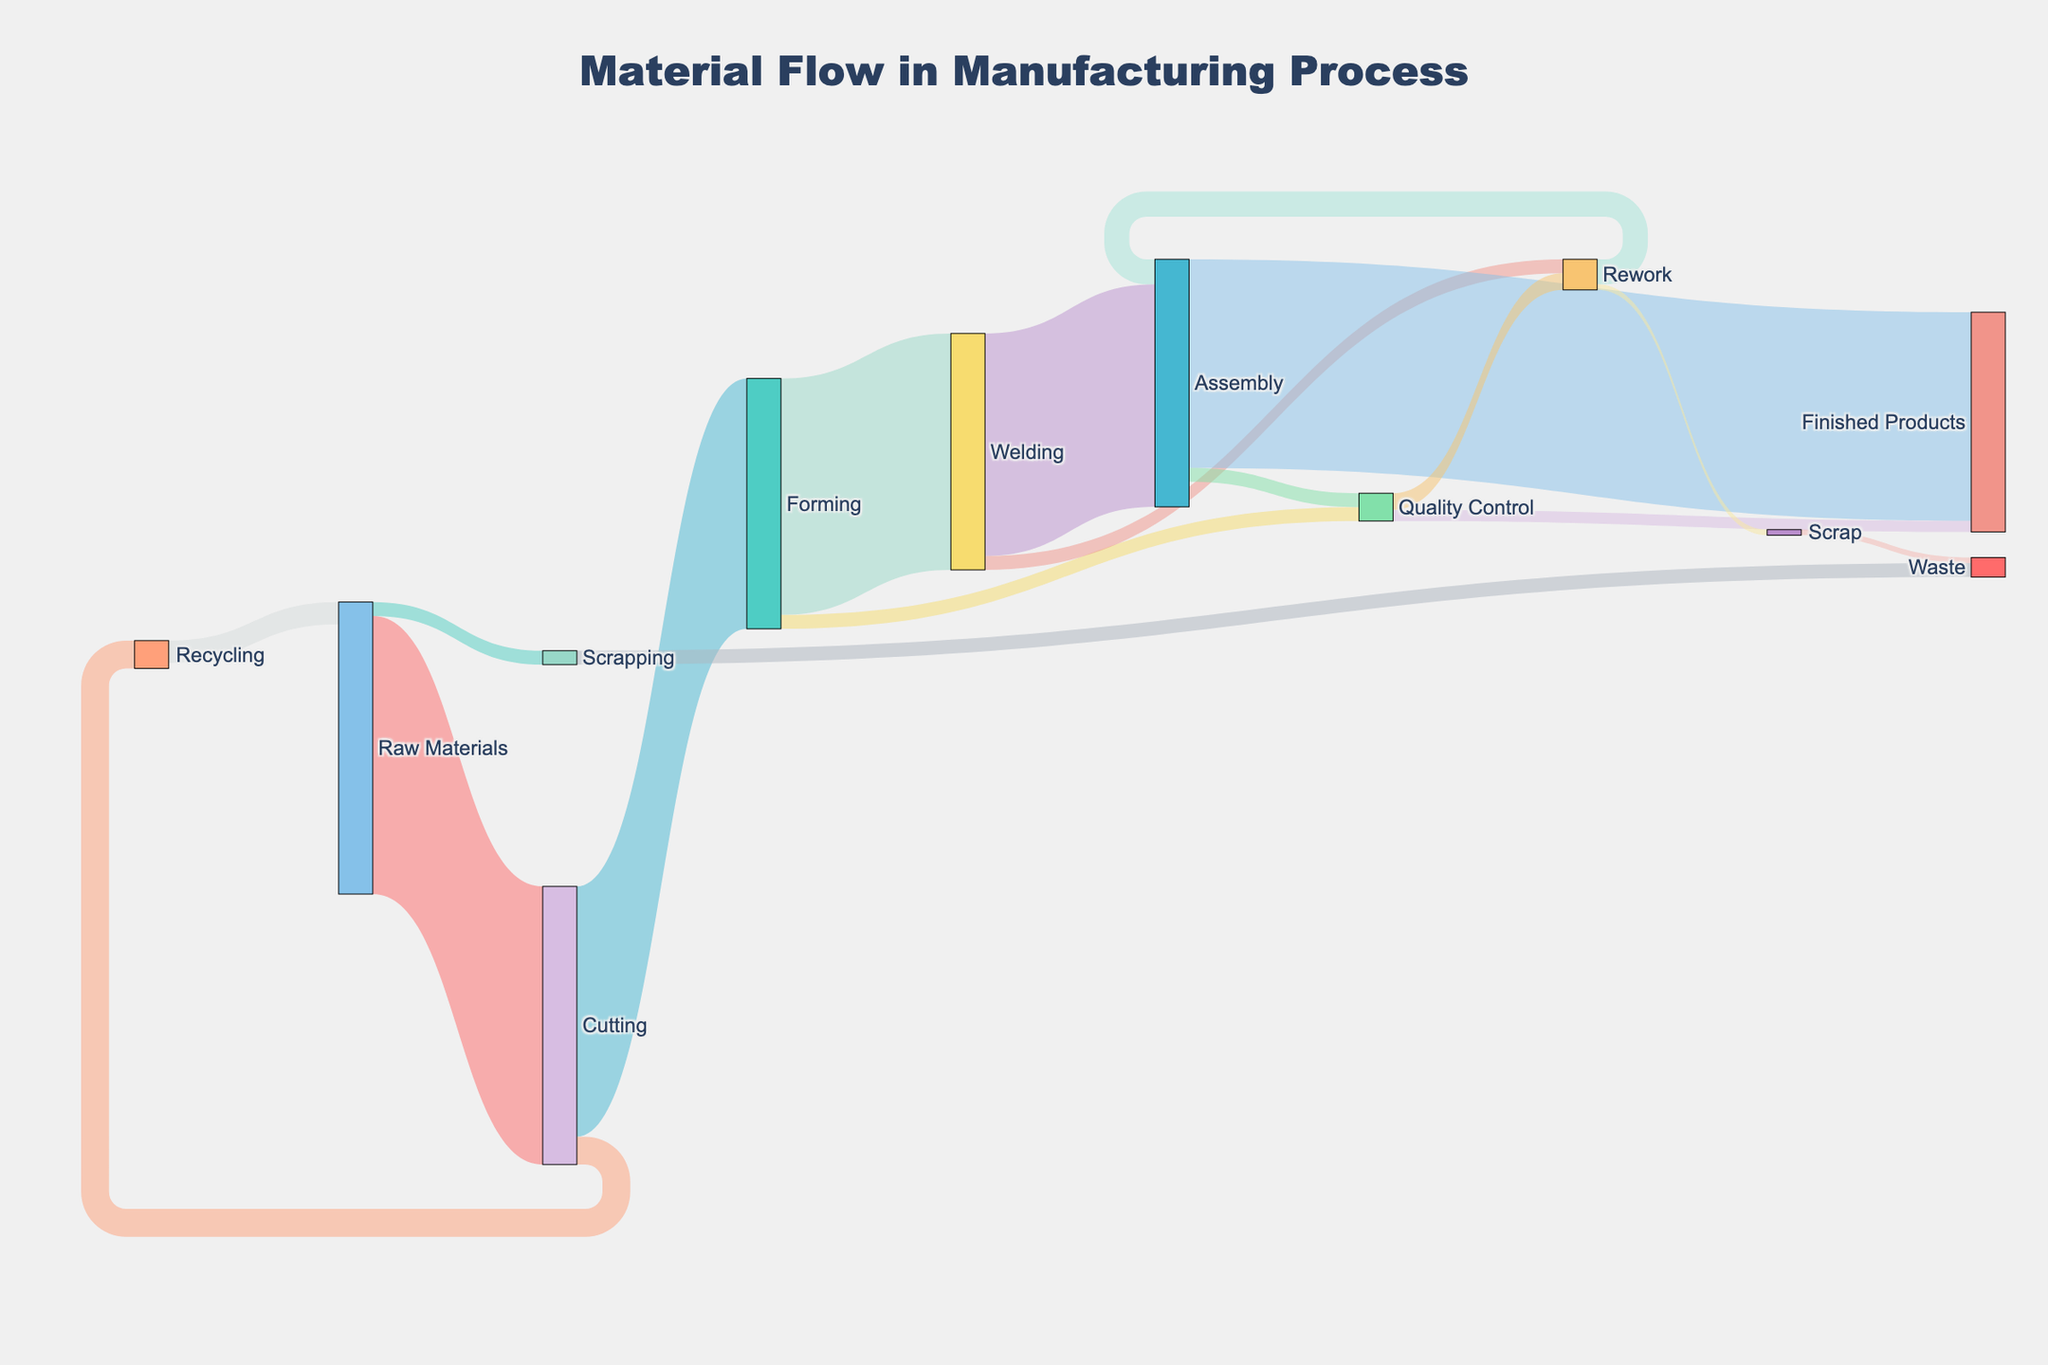what is the title of this diagram? The title of a diagram is typically found at the top and is often larger and more prominent than other text. It helps identify the main topic or subject of the figure.
Answer: Material Flow in Manufacturing Process How many flow paths are there from Raw Materials to the next stages? The figure shows paths originating from Raw Materials and splitting into different stages. By counting these, we can determine the total number of paths.
Answer: 2 What's the total material flow reaching the Assembly stage? To find the total material flow reaching the Assembly stage, look at all paths leading to it. These include paths from Welding and Rework. Their values are summed up: 800 (Welding) + 90 (Rework).
Answer: 890 How much material ends up as Waste? Waste can occur from the Scrapping and Scrap stages. We sum these amounts: 50 (Scrapping) + 20 (Scrap).
Answer: 70 Compare the amount of material that goes to Quality Control from Forming and Assembly. Which one is greater? Look at the flow values to Quality Control from both stages. Forming sends 50 units, while Assembly sends another 50 units. Since both values are the same, neither is greater.
Answer: Neither, they are equal How much of the material from Welding ends up as Rework? Trace the path from Welding to Rework and take that specific value which represents the amount of material.
Answer: 50 What percentage of the initial Raw Materials end up as Finished Products directly through Assembly? The total Raw Materials are 1000 units. From Assembly, 750 units become Finished Products. Calculate the percentage as (750/1000) * 100.
Answer: 75% Trace the recycling loop: How much material is recycled back into Raw Materials from the Recycling stage? The figure shows material being recycled from the Cutting stage back to Raw Materials through the Recycling loop. The value for this flow is found in the diagram.
Answer: 80 Which stage has the highest single material flow? By examining the values of each flow path, identify the highest single value among all paths.
Answer: Cutting to Forming, 900 